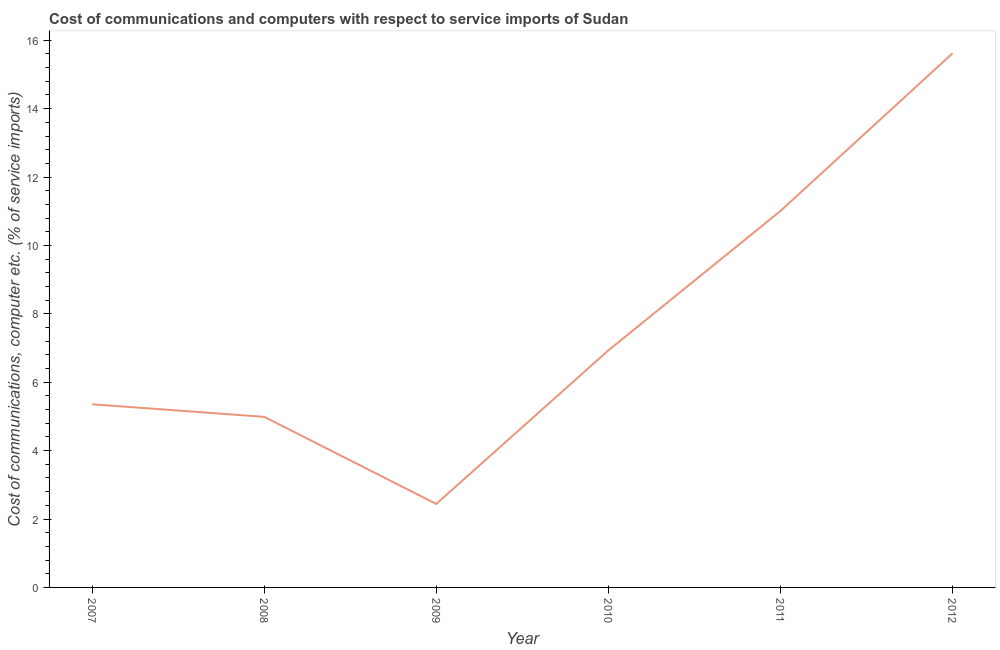What is the cost of communications and computer in 2008?
Your response must be concise. 4.99. Across all years, what is the maximum cost of communications and computer?
Your answer should be very brief. 15.62. Across all years, what is the minimum cost of communications and computer?
Offer a terse response. 2.44. In which year was the cost of communications and computer maximum?
Ensure brevity in your answer.  2012. In which year was the cost of communications and computer minimum?
Give a very brief answer. 2009. What is the sum of the cost of communications and computer?
Your response must be concise. 46.34. What is the difference between the cost of communications and computer in 2008 and 2012?
Offer a very short reply. -10.63. What is the average cost of communications and computer per year?
Your answer should be compact. 7.72. What is the median cost of communications and computer?
Make the answer very short. 6.14. In how many years, is the cost of communications and computer greater than 4 %?
Provide a succinct answer. 5. What is the ratio of the cost of communications and computer in 2007 to that in 2008?
Ensure brevity in your answer.  1.07. Is the cost of communications and computer in 2007 less than that in 2009?
Your answer should be very brief. No. What is the difference between the highest and the second highest cost of communications and computer?
Give a very brief answer. 4.61. What is the difference between the highest and the lowest cost of communications and computer?
Offer a terse response. 13.18. Does the cost of communications and computer monotonically increase over the years?
Offer a very short reply. No. How many lines are there?
Your answer should be very brief. 1. How many years are there in the graph?
Your answer should be compact. 6. Are the values on the major ticks of Y-axis written in scientific E-notation?
Provide a short and direct response. No. Does the graph contain any zero values?
Ensure brevity in your answer.  No. What is the title of the graph?
Provide a succinct answer. Cost of communications and computers with respect to service imports of Sudan. What is the label or title of the X-axis?
Keep it short and to the point. Year. What is the label or title of the Y-axis?
Make the answer very short. Cost of communications, computer etc. (% of service imports). What is the Cost of communications, computer etc. (% of service imports) in 2007?
Offer a terse response. 5.36. What is the Cost of communications, computer etc. (% of service imports) in 2008?
Offer a very short reply. 4.99. What is the Cost of communications, computer etc. (% of service imports) in 2009?
Provide a succinct answer. 2.44. What is the Cost of communications, computer etc. (% of service imports) of 2010?
Keep it short and to the point. 6.93. What is the Cost of communications, computer etc. (% of service imports) of 2011?
Keep it short and to the point. 11.01. What is the Cost of communications, computer etc. (% of service imports) of 2012?
Your answer should be compact. 15.62. What is the difference between the Cost of communications, computer etc. (% of service imports) in 2007 and 2008?
Provide a short and direct response. 0.37. What is the difference between the Cost of communications, computer etc. (% of service imports) in 2007 and 2009?
Offer a very short reply. 2.91. What is the difference between the Cost of communications, computer etc. (% of service imports) in 2007 and 2010?
Make the answer very short. -1.57. What is the difference between the Cost of communications, computer etc. (% of service imports) in 2007 and 2011?
Your answer should be very brief. -5.65. What is the difference between the Cost of communications, computer etc. (% of service imports) in 2007 and 2012?
Offer a very short reply. -10.26. What is the difference between the Cost of communications, computer etc. (% of service imports) in 2008 and 2009?
Provide a short and direct response. 2.55. What is the difference between the Cost of communications, computer etc. (% of service imports) in 2008 and 2010?
Provide a short and direct response. -1.94. What is the difference between the Cost of communications, computer etc. (% of service imports) in 2008 and 2011?
Ensure brevity in your answer.  -6.02. What is the difference between the Cost of communications, computer etc. (% of service imports) in 2008 and 2012?
Provide a short and direct response. -10.63. What is the difference between the Cost of communications, computer etc. (% of service imports) in 2009 and 2010?
Provide a succinct answer. -4.49. What is the difference between the Cost of communications, computer etc. (% of service imports) in 2009 and 2011?
Offer a very short reply. -8.56. What is the difference between the Cost of communications, computer etc. (% of service imports) in 2009 and 2012?
Your answer should be compact. -13.18. What is the difference between the Cost of communications, computer etc. (% of service imports) in 2010 and 2011?
Make the answer very short. -4.08. What is the difference between the Cost of communications, computer etc. (% of service imports) in 2010 and 2012?
Your answer should be compact. -8.69. What is the difference between the Cost of communications, computer etc. (% of service imports) in 2011 and 2012?
Offer a very short reply. -4.61. What is the ratio of the Cost of communications, computer etc. (% of service imports) in 2007 to that in 2008?
Make the answer very short. 1.07. What is the ratio of the Cost of communications, computer etc. (% of service imports) in 2007 to that in 2009?
Keep it short and to the point. 2.19. What is the ratio of the Cost of communications, computer etc. (% of service imports) in 2007 to that in 2010?
Give a very brief answer. 0.77. What is the ratio of the Cost of communications, computer etc. (% of service imports) in 2007 to that in 2011?
Provide a short and direct response. 0.49. What is the ratio of the Cost of communications, computer etc. (% of service imports) in 2007 to that in 2012?
Keep it short and to the point. 0.34. What is the ratio of the Cost of communications, computer etc. (% of service imports) in 2008 to that in 2009?
Keep it short and to the point. 2.04. What is the ratio of the Cost of communications, computer etc. (% of service imports) in 2008 to that in 2010?
Offer a very short reply. 0.72. What is the ratio of the Cost of communications, computer etc. (% of service imports) in 2008 to that in 2011?
Provide a succinct answer. 0.45. What is the ratio of the Cost of communications, computer etc. (% of service imports) in 2008 to that in 2012?
Your response must be concise. 0.32. What is the ratio of the Cost of communications, computer etc. (% of service imports) in 2009 to that in 2010?
Give a very brief answer. 0.35. What is the ratio of the Cost of communications, computer etc. (% of service imports) in 2009 to that in 2011?
Keep it short and to the point. 0.22. What is the ratio of the Cost of communications, computer etc. (% of service imports) in 2009 to that in 2012?
Give a very brief answer. 0.16. What is the ratio of the Cost of communications, computer etc. (% of service imports) in 2010 to that in 2011?
Offer a terse response. 0.63. What is the ratio of the Cost of communications, computer etc. (% of service imports) in 2010 to that in 2012?
Give a very brief answer. 0.44. What is the ratio of the Cost of communications, computer etc. (% of service imports) in 2011 to that in 2012?
Offer a very short reply. 0.7. 